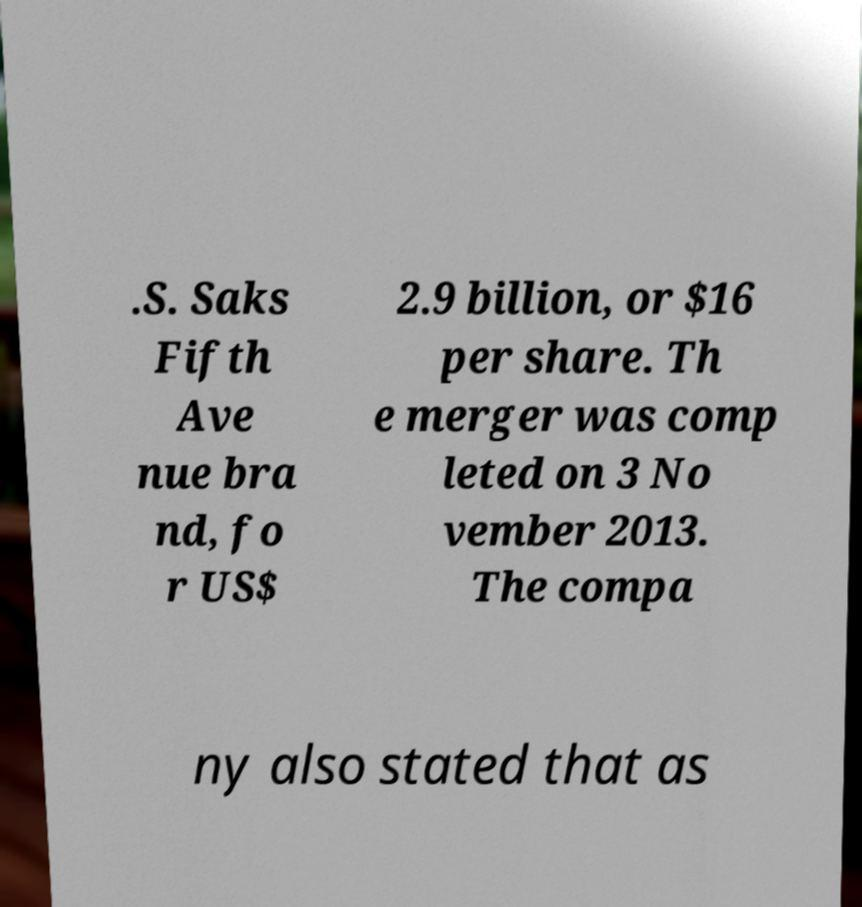I need the written content from this picture converted into text. Can you do that? .S. Saks Fifth Ave nue bra nd, fo r US$ 2.9 billion, or $16 per share. Th e merger was comp leted on 3 No vember 2013. The compa ny also stated that as 